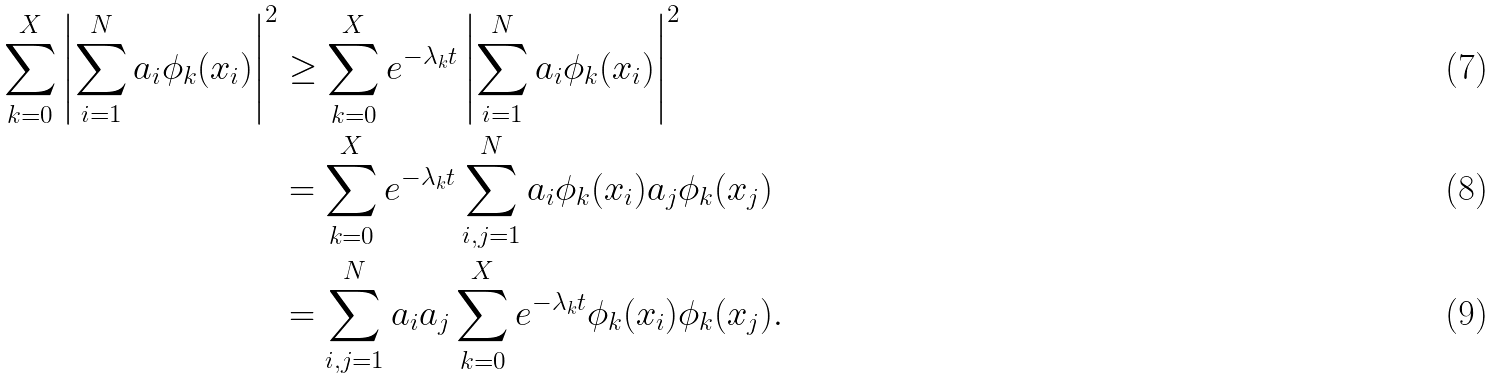Convert formula to latex. <formula><loc_0><loc_0><loc_500><loc_500>\sum _ { k = 0 } ^ { X } \left | \sum _ { i = 1 } ^ { N } { a _ { i } \phi _ { k } ( x _ { i } ) } \right | ^ { 2 } & \geq \sum _ { k = 0 } ^ { X } e ^ { - \lambda _ { k } t } \left | \sum _ { i = 1 } ^ { N } { a _ { i } \phi _ { k } ( x _ { i } ) } \right | ^ { 2 } \\ & = \sum _ { k = 0 } ^ { X } e ^ { - \lambda _ { k } t } \sum _ { i , j = 1 } ^ { N } { a _ { i } \phi _ { k } ( x _ { i } ) a _ { j } \phi _ { k } ( x _ { j } ) } \\ & = \sum _ { i , j = 1 } ^ { N } { a _ { i } a _ { j } \sum _ { k = 0 } ^ { X } e ^ { - \lambda _ { k } t } \phi _ { k } ( x _ { i } ) \phi _ { k } ( x _ { j } ) } .</formula> 